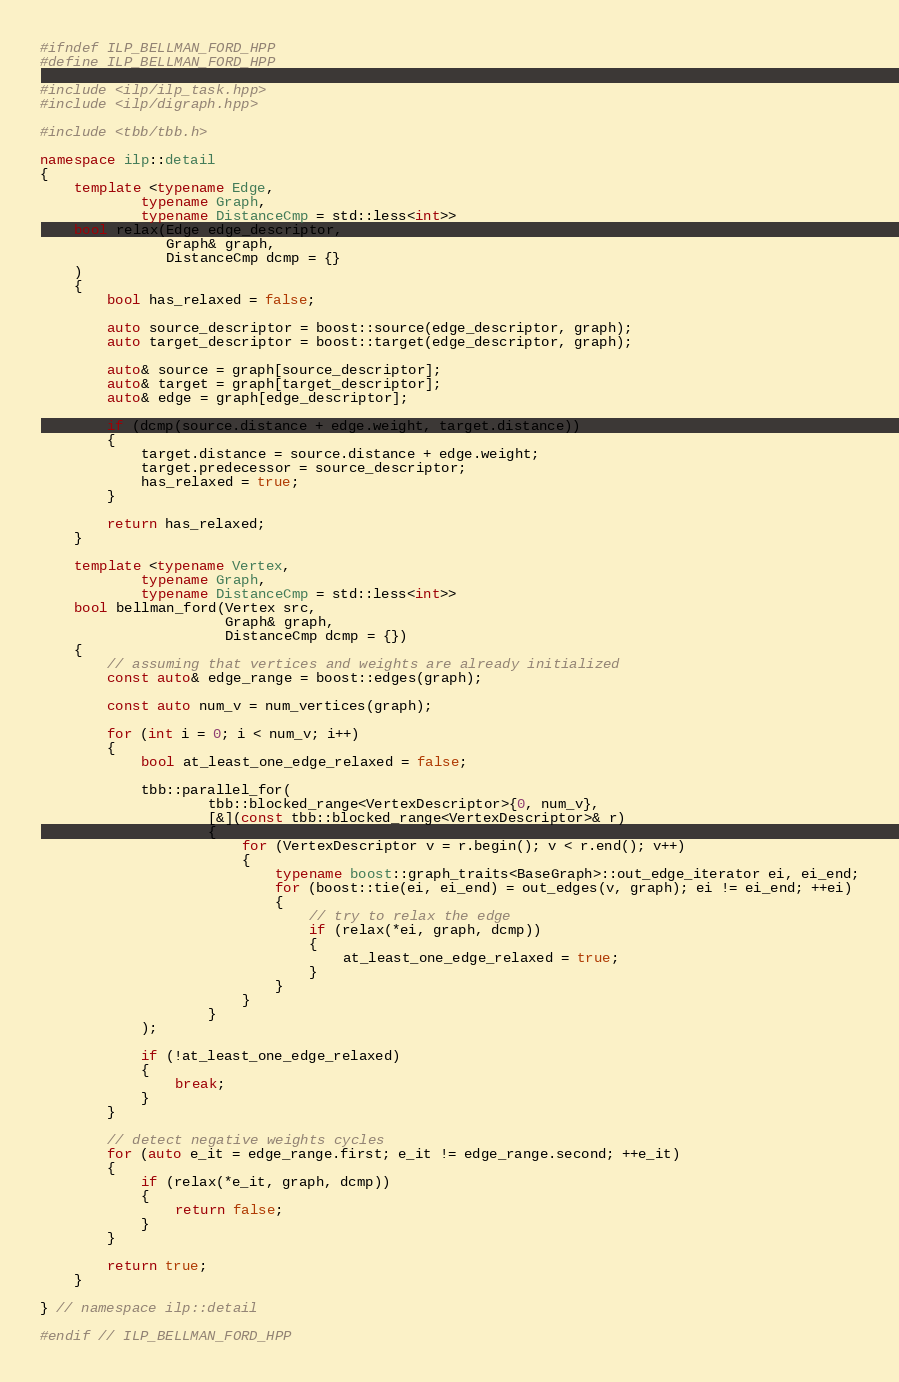<code> <loc_0><loc_0><loc_500><loc_500><_C++_>#ifndef ILP_BELLMAN_FORD_HPP
#define ILP_BELLMAN_FORD_HPP

#include <ilp/ilp_task.hpp>
#include <ilp/digraph.hpp>

#include <tbb/tbb.h>

namespace ilp::detail
{
    template <typename Edge,
            typename Graph,
            typename DistanceCmp = std::less<int>>
    bool relax(Edge edge_descriptor,
               Graph& graph,
               DistanceCmp dcmp = {}
    )
    {
        bool has_relaxed = false;

        auto source_descriptor = boost::source(edge_descriptor, graph);
        auto target_descriptor = boost::target(edge_descriptor, graph);

        auto& source = graph[source_descriptor];
        auto& target = graph[target_descriptor];
        auto& edge = graph[edge_descriptor];

        if (dcmp(source.distance + edge.weight, target.distance))
        {
            target.distance = source.distance + edge.weight;
            target.predecessor = source_descriptor;
            has_relaxed = true;
        }

        return has_relaxed;
    }

    template <typename Vertex,
            typename Graph,
            typename DistanceCmp = std::less<int>>
    bool bellman_ford(Vertex src,
                      Graph& graph,
                      DistanceCmp dcmp = {})
    {
        // assuming that vertices and weights are already initialized
        const auto& edge_range = boost::edges(graph);

        const auto num_v = num_vertices(graph);

        for (int i = 0; i < num_v; i++)
        {
            bool at_least_one_edge_relaxed = false;

            tbb::parallel_for(
                    tbb::blocked_range<VertexDescriptor>{0, num_v},
                    [&](const tbb::blocked_range<VertexDescriptor>& r)
                    {
                        for (VertexDescriptor v = r.begin(); v < r.end(); v++)
                        {
                            typename boost::graph_traits<BaseGraph>::out_edge_iterator ei, ei_end;
                            for (boost::tie(ei, ei_end) = out_edges(v, graph); ei != ei_end; ++ei)
                            {
                                // try to relax the edge
                                if (relax(*ei, graph, dcmp))
                                {
                                    at_least_one_edge_relaxed = true;
                                }
                            }
                        }
                    }
            );

            if (!at_least_one_edge_relaxed)
            {
                break;
            }
        }

        // detect negative weights cycles
        for (auto e_it = edge_range.first; e_it != edge_range.second; ++e_it)
        {
            if (relax(*e_it, graph, dcmp))
            {
                return false;
            }
        }

        return true;
    }

} // namespace ilp::detail

#endif // ILP_BELLMAN_FORD_HPP

</code> 